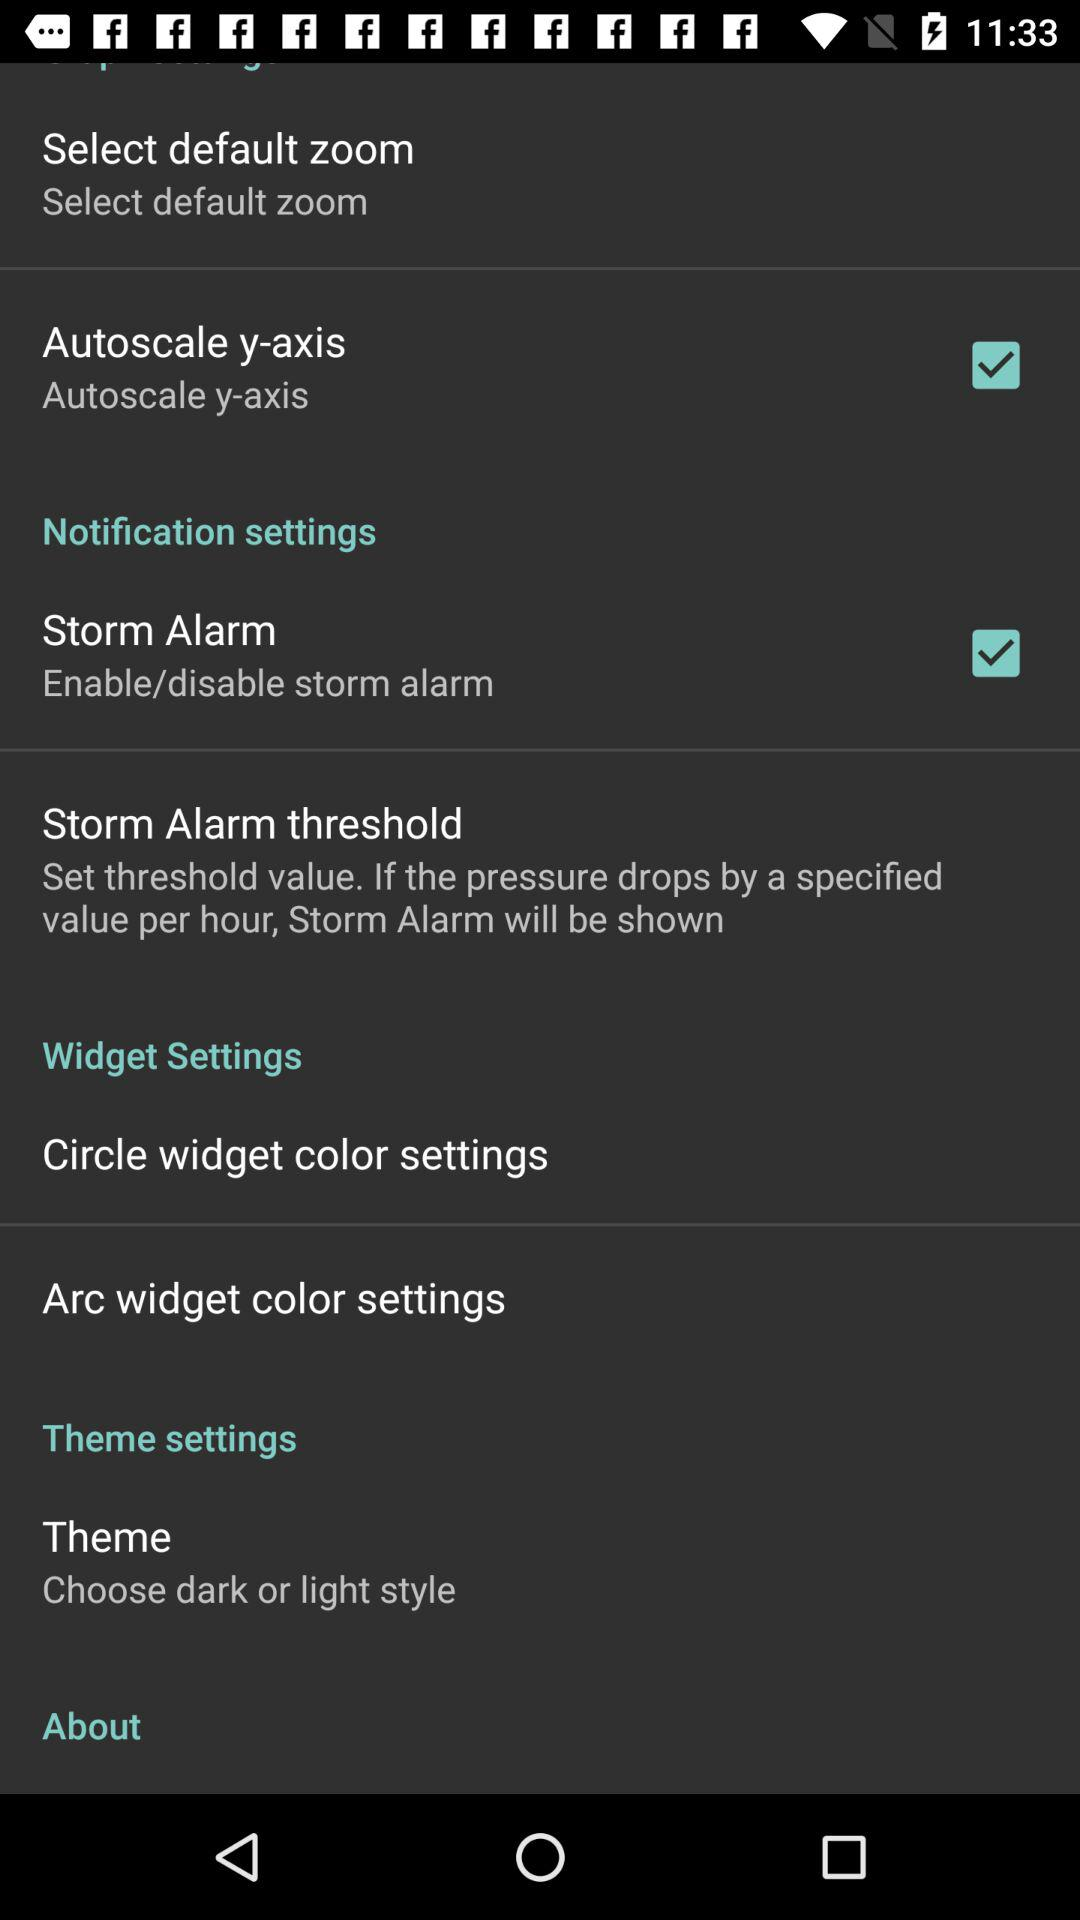Was dark or light style chosen?
When the provided information is insufficient, respond with <no answer>. <no answer> 